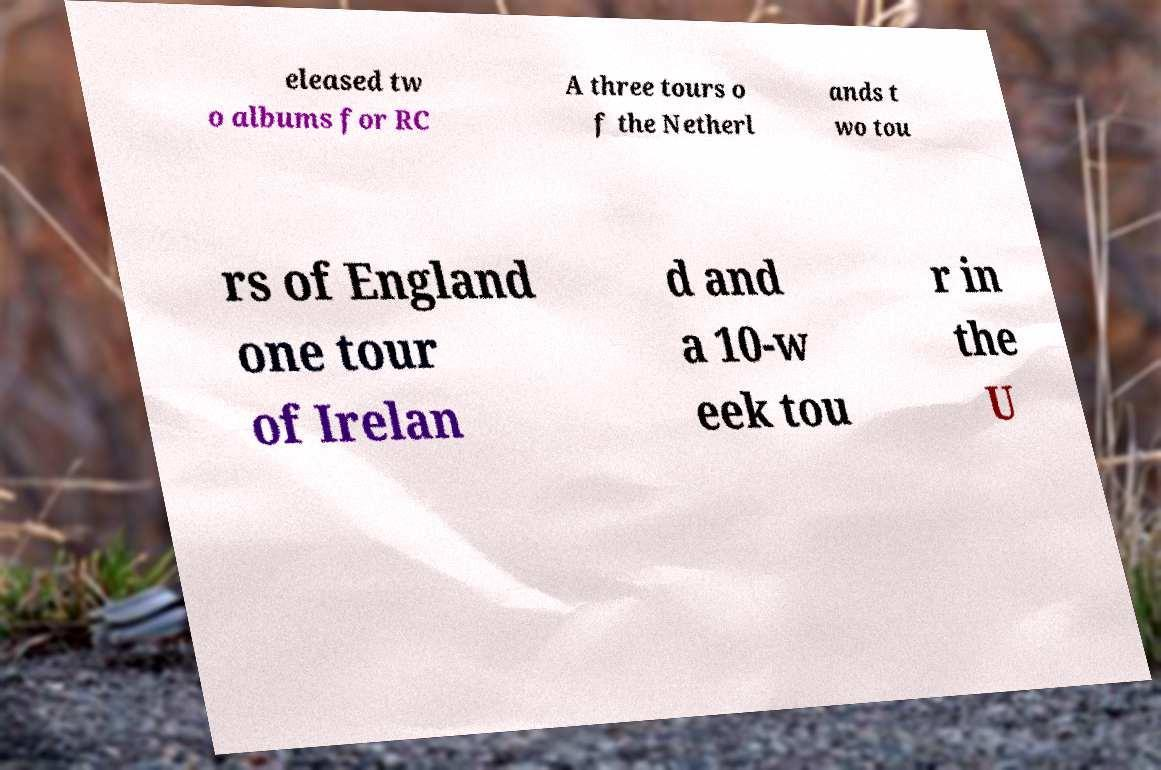I need the written content from this picture converted into text. Can you do that? eleased tw o albums for RC A three tours o f the Netherl ands t wo tou rs of England one tour of Irelan d and a 10-w eek tou r in the U 